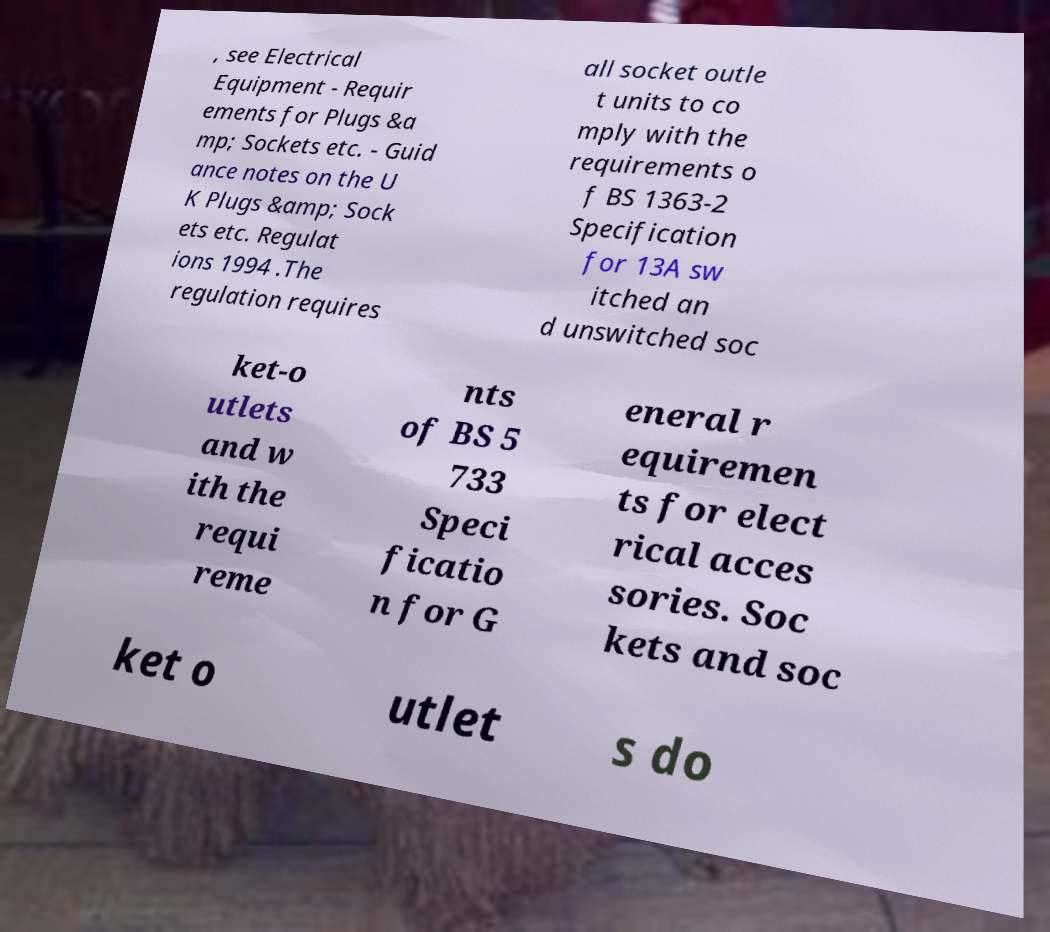Please read and relay the text visible in this image. What does it say? , see Electrical Equipment - Requir ements for Plugs &a mp; Sockets etc. - Guid ance notes on the U K Plugs &amp; Sock ets etc. Regulat ions 1994 .The regulation requires all socket outle t units to co mply with the requirements o f BS 1363-2 Specification for 13A sw itched an d unswitched soc ket-o utlets and w ith the requi reme nts of BS 5 733 Speci ficatio n for G eneral r equiremen ts for elect rical acces sories. Soc kets and soc ket o utlet s do 